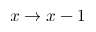<formula> <loc_0><loc_0><loc_500><loc_500>x \rightarrow x - 1</formula> 